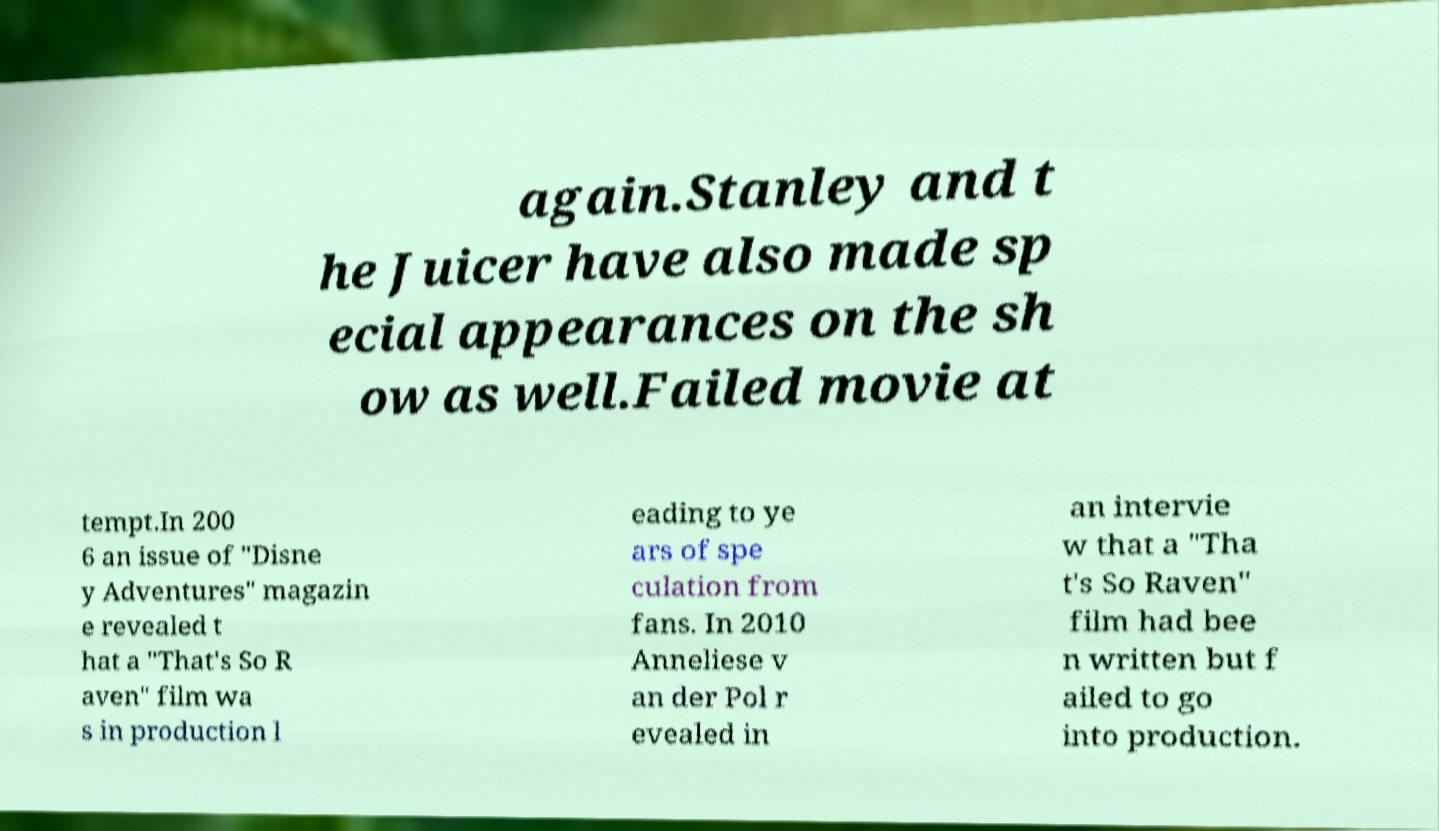Please read and relay the text visible in this image. What does it say? again.Stanley and t he Juicer have also made sp ecial appearances on the sh ow as well.Failed movie at tempt.In 200 6 an issue of "Disne y Adventures" magazin e revealed t hat a "That's So R aven" film wa s in production l eading to ye ars of spe culation from fans. In 2010 Anneliese v an der Pol r evealed in an intervie w that a "Tha t's So Raven" film had bee n written but f ailed to go into production. 